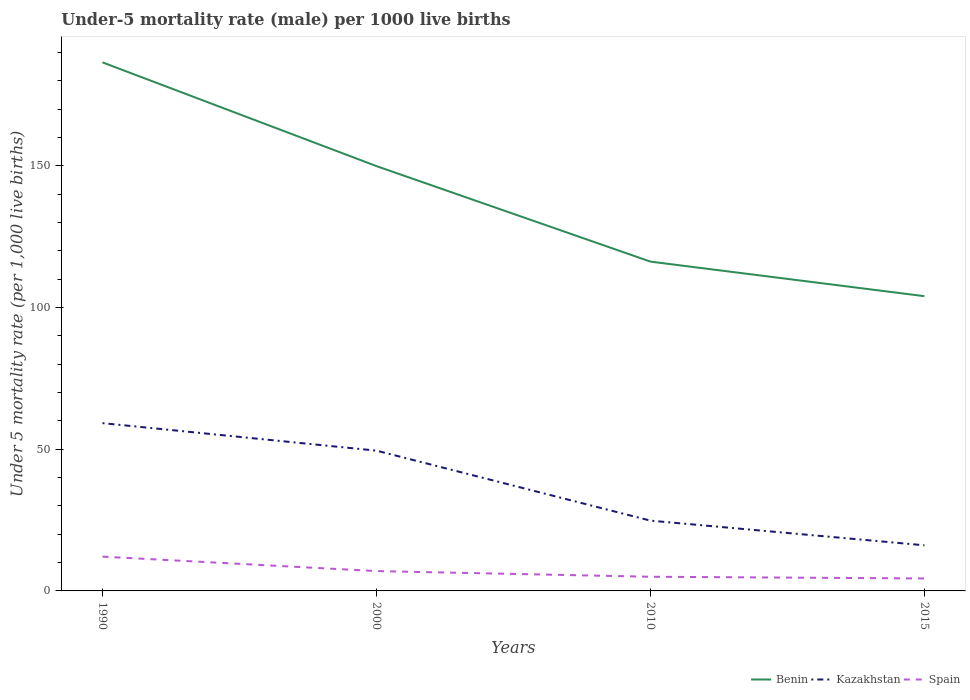How many different coloured lines are there?
Offer a very short reply. 3. Across all years, what is the maximum under-five mortality rate in Benin?
Provide a short and direct response. 104. In which year was the under-five mortality rate in Benin maximum?
Ensure brevity in your answer.  2015. What is the total under-five mortality rate in Kazakhstan in the graph?
Your answer should be compact. 33.4. What is the difference between the highest and the second highest under-five mortality rate in Spain?
Ensure brevity in your answer.  7.7. Is the under-five mortality rate in Kazakhstan strictly greater than the under-five mortality rate in Benin over the years?
Your answer should be very brief. Yes. How many lines are there?
Offer a very short reply. 3. How many years are there in the graph?
Offer a terse response. 4. What is the difference between two consecutive major ticks on the Y-axis?
Ensure brevity in your answer.  50. Does the graph contain any zero values?
Keep it short and to the point. No. Where does the legend appear in the graph?
Give a very brief answer. Bottom right. How many legend labels are there?
Make the answer very short. 3. How are the legend labels stacked?
Offer a terse response. Horizontal. What is the title of the graph?
Give a very brief answer. Under-5 mortality rate (male) per 1000 live births. What is the label or title of the X-axis?
Your response must be concise. Years. What is the label or title of the Y-axis?
Ensure brevity in your answer.  Under 5 mortality rate (per 1,0 live births). What is the Under 5 mortality rate (per 1,000 live births) of Benin in 1990?
Offer a very short reply. 186.5. What is the Under 5 mortality rate (per 1,000 live births) in Kazakhstan in 1990?
Provide a succinct answer. 59.2. What is the Under 5 mortality rate (per 1,000 live births) in Spain in 1990?
Make the answer very short. 12.1. What is the Under 5 mortality rate (per 1,000 live births) of Benin in 2000?
Your response must be concise. 149.9. What is the Under 5 mortality rate (per 1,000 live births) of Kazakhstan in 2000?
Give a very brief answer. 49.5. What is the Under 5 mortality rate (per 1,000 live births) in Spain in 2000?
Your response must be concise. 7. What is the Under 5 mortality rate (per 1,000 live births) in Benin in 2010?
Ensure brevity in your answer.  116.2. What is the Under 5 mortality rate (per 1,000 live births) of Kazakhstan in 2010?
Give a very brief answer. 24.8. What is the Under 5 mortality rate (per 1,000 live births) of Spain in 2010?
Give a very brief answer. 5. What is the Under 5 mortality rate (per 1,000 live births) in Benin in 2015?
Your answer should be compact. 104. Across all years, what is the maximum Under 5 mortality rate (per 1,000 live births) in Benin?
Ensure brevity in your answer.  186.5. Across all years, what is the maximum Under 5 mortality rate (per 1,000 live births) of Kazakhstan?
Offer a very short reply. 59.2. Across all years, what is the minimum Under 5 mortality rate (per 1,000 live births) of Benin?
Your answer should be very brief. 104. Across all years, what is the minimum Under 5 mortality rate (per 1,000 live births) in Kazakhstan?
Your answer should be compact. 16.1. Across all years, what is the minimum Under 5 mortality rate (per 1,000 live births) in Spain?
Offer a terse response. 4.4. What is the total Under 5 mortality rate (per 1,000 live births) of Benin in the graph?
Provide a succinct answer. 556.6. What is the total Under 5 mortality rate (per 1,000 live births) in Kazakhstan in the graph?
Make the answer very short. 149.6. What is the difference between the Under 5 mortality rate (per 1,000 live births) in Benin in 1990 and that in 2000?
Make the answer very short. 36.6. What is the difference between the Under 5 mortality rate (per 1,000 live births) in Benin in 1990 and that in 2010?
Offer a terse response. 70.3. What is the difference between the Under 5 mortality rate (per 1,000 live births) in Kazakhstan in 1990 and that in 2010?
Provide a succinct answer. 34.4. What is the difference between the Under 5 mortality rate (per 1,000 live births) in Benin in 1990 and that in 2015?
Your answer should be very brief. 82.5. What is the difference between the Under 5 mortality rate (per 1,000 live births) of Kazakhstan in 1990 and that in 2015?
Offer a very short reply. 43.1. What is the difference between the Under 5 mortality rate (per 1,000 live births) of Spain in 1990 and that in 2015?
Your answer should be compact. 7.7. What is the difference between the Under 5 mortality rate (per 1,000 live births) of Benin in 2000 and that in 2010?
Offer a terse response. 33.7. What is the difference between the Under 5 mortality rate (per 1,000 live births) in Kazakhstan in 2000 and that in 2010?
Your answer should be compact. 24.7. What is the difference between the Under 5 mortality rate (per 1,000 live births) in Spain in 2000 and that in 2010?
Make the answer very short. 2. What is the difference between the Under 5 mortality rate (per 1,000 live births) in Benin in 2000 and that in 2015?
Ensure brevity in your answer.  45.9. What is the difference between the Under 5 mortality rate (per 1,000 live births) in Kazakhstan in 2000 and that in 2015?
Your response must be concise. 33.4. What is the difference between the Under 5 mortality rate (per 1,000 live births) in Benin in 2010 and that in 2015?
Offer a terse response. 12.2. What is the difference between the Under 5 mortality rate (per 1,000 live births) in Benin in 1990 and the Under 5 mortality rate (per 1,000 live births) in Kazakhstan in 2000?
Give a very brief answer. 137. What is the difference between the Under 5 mortality rate (per 1,000 live births) of Benin in 1990 and the Under 5 mortality rate (per 1,000 live births) of Spain in 2000?
Provide a succinct answer. 179.5. What is the difference between the Under 5 mortality rate (per 1,000 live births) of Kazakhstan in 1990 and the Under 5 mortality rate (per 1,000 live births) of Spain in 2000?
Provide a short and direct response. 52.2. What is the difference between the Under 5 mortality rate (per 1,000 live births) in Benin in 1990 and the Under 5 mortality rate (per 1,000 live births) in Kazakhstan in 2010?
Provide a short and direct response. 161.7. What is the difference between the Under 5 mortality rate (per 1,000 live births) in Benin in 1990 and the Under 5 mortality rate (per 1,000 live births) in Spain in 2010?
Keep it short and to the point. 181.5. What is the difference between the Under 5 mortality rate (per 1,000 live births) of Kazakhstan in 1990 and the Under 5 mortality rate (per 1,000 live births) of Spain in 2010?
Give a very brief answer. 54.2. What is the difference between the Under 5 mortality rate (per 1,000 live births) of Benin in 1990 and the Under 5 mortality rate (per 1,000 live births) of Kazakhstan in 2015?
Your answer should be compact. 170.4. What is the difference between the Under 5 mortality rate (per 1,000 live births) of Benin in 1990 and the Under 5 mortality rate (per 1,000 live births) of Spain in 2015?
Keep it short and to the point. 182.1. What is the difference between the Under 5 mortality rate (per 1,000 live births) of Kazakhstan in 1990 and the Under 5 mortality rate (per 1,000 live births) of Spain in 2015?
Your answer should be very brief. 54.8. What is the difference between the Under 5 mortality rate (per 1,000 live births) in Benin in 2000 and the Under 5 mortality rate (per 1,000 live births) in Kazakhstan in 2010?
Provide a short and direct response. 125.1. What is the difference between the Under 5 mortality rate (per 1,000 live births) of Benin in 2000 and the Under 5 mortality rate (per 1,000 live births) of Spain in 2010?
Your answer should be compact. 144.9. What is the difference between the Under 5 mortality rate (per 1,000 live births) of Kazakhstan in 2000 and the Under 5 mortality rate (per 1,000 live births) of Spain in 2010?
Offer a very short reply. 44.5. What is the difference between the Under 5 mortality rate (per 1,000 live births) in Benin in 2000 and the Under 5 mortality rate (per 1,000 live births) in Kazakhstan in 2015?
Your response must be concise. 133.8. What is the difference between the Under 5 mortality rate (per 1,000 live births) in Benin in 2000 and the Under 5 mortality rate (per 1,000 live births) in Spain in 2015?
Give a very brief answer. 145.5. What is the difference between the Under 5 mortality rate (per 1,000 live births) of Kazakhstan in 2000 and the Under 5 mortality rate (per 1,000 live births) of Spain in 2015?
Provide a short and direct response. 45.1. What is the difference between the Under 5 mortality rate (per 1,000 live births) of Benin in 2010 and the Under 5 mortality rate (per 1,000 live births) of Kazakhstan in 2015?
Your response must be concise. 100.1. What is the difference between the Under 5 mortality rate (per 1,000 live births) of Benin in 2010 and the Under 5 mortality rate (per 1,000 live births) of Spain in 2015?
Offer a terse response. 111.8. What is the difference between the Under 5 mortality rate (per 1,000 live births) in Kazakhstan in 2010 and the Under 5 mortality rate (per 1,000 live births) in Spain in 2015?
Offer a terse response. 20.4. What is the average Under 5 mortality rate (per 1,000 live births) in Benin per year?
Offer a terse response. 139.15. What is the average Under 5 mortality rate (per 1,000 live births) in Kazakhstan per year?
Your answer should be compact. 37.4. What is the average Under 5 mortality rate (per 1,000 live births) in Spain per year?
Keep it short and to the point. 7.12. In the year 1990, what is the difference between the Under 5 mortality rate (per 1,000 live births) of Benin and Under 5 mortality rate (per 1,000 live births) of Kazakhstan?
Offer a terse response. 127.3. In the year 1990, what is the difference between the Under 5 mortality rate (per 1,000 live births) of Benin and Under 5 mortality rate (per 1,000 live births) of Spain?
Your answer should be compact. 174.4. In the year 1990, what is the difference between the Under 5 mortality rate (per 1,000 live births) of Kazakhstan and Under 5 mortality rate (per 1,000 live births) of Spain?
Ensure brevity in your answer.  47.1. In the year 2000, what is the difference between the Under 5 mortality rate (per 1,000 live births) of Benin and Under 5 mortality rate (per 1,000 live births) of Kazakhstan?
Your answer should be very brief. 100.4. In the year 2000, what is the difference between the Under 5 mortality rate (per 1,000 live births) of Benin and Under 5 mortality rate (per 1,000 live births) of Spain?
Give a very brief answer. 142.9. In the year 2000, what is the difference between the Under 5 mortality rate (per 1,000 live births) in Kazakhstan and Under 5 mortality rate (per 1,000 live births) in Spain?
Your response must be concise. 42.5. In the year 2010, what is the difference between the Under 5 mortality rate (per 1,000 live births) in Benin and Under 5 mortality rate (per 1,000 live births) in Kazakhstan?
Ensure brevity in your answer.  91.4. In the year 2010, what is the difference between the Under 5 mortality rate (per 1,000 live births) of Benin and Under 5 mortality rate (per 1,000 live births) of Spain?
Provide a succinct answer. 111.2. In the year 2010, what is the difference between the Under 5 mortality rate (per 1,000 live births) of Kazakhstan and Under 5 mortality rate (per 1,000 live births) of Spain?
Offer a terse response. 19.8. In the year 2015, what is the difference between the Under 5 mortality rate (per 1,000 live births) in Benin and Under 5 mortality rate (per 1,000 live births) in Kazakhstan?
Your answer should be very brief. 87.9. In the year 2015, what is the difference between the Under 5 mortality rate (per 1,000 live births) of Benin and Under 5 mortality rate (per 1,000 live births) of Spain?
Keep it short and to the point. 99.6. What is the ratio of the Under 5 mortality rate (per 1,000 live births) of Benin in 1990 to that in 2000?
Keep it short and to the point. 1.24. What is the ratio of the Under 5 mortality rate (per 1,000 live births) in Kazakhstan in 1990 to that in 2000?
Ensure brevity in your answer.  1.2. What is the ratio of the Under 5 mortality rate (per 1,000 live births) of Spain in 1990 to that in 2000?
Make the answer very short. 1.73. What is the ratio of the Under 5 mortality rate (per 1,000 live births) of Benin in 1990 to that in 2010?
Provide a succinct answer. 1.6. What is the ratio of the Under 5 mortality rate (per 1,000 live births) in Kazakhstan in 1990 to that in 2010?
Your answer should be compact. 2.39. What is the ratio of the Under 5 mortality rate (per 1,000 live births) of Spain in 1990 to that in 2010?
Offer a terse response. 2.42. What is the ratio of the Under 5 mortality rate (per 1,000 live births) of Benin in 1990 to that in 2015?
Your response must be concise. 1.79. What is the ratio of the Under 5 mortality rate (per 1,000 live births) of Kazakhstan in 1990 to that in 2015?
Ensure brevity in your answer.  3.68. What is the ratio of the Under 5 mortality rate (per 1,000 live births) in Spain in 1990 to that in 2015?
Offer a terse response. 2.75. What is the ratio of the Under 5 mortality rate (per 1,000 live births) in Benin in 2000 to that in 2010?
Ensure brevity in your answer.  1.29. What is the ratio of the Under 5 mortality rate (per 1,000 live births) of Kazakhstan in 2000 to that in 2010?
Ensure brevity in your answer.  2. What is the ratio of the Under 5 mortality rate (per 1,000 live births) of Benin in 2000 to that in 2015?
Provide a short and direct response. 1.44. What is the ratio of the Under 5 mortality rate (per 1,000 live births) in Kazakhstan in 2000 to that in 2015?
Your response must be concise. 3.07. What is the ratio of the Under 5 mortality rate (per 1,000 live births) of Spain in 2000 to that in 2015?
Ensure brevity in your answer.  1.59. What is the ratio of the Under 5 mortality rate (per 1,000 live births) in Benin in 2010 to that in 2015?
Offer a terse response. 1.12. What is the ratio of the Under 5 mortality rate (per 1,000 live births) of Kazakhstan in 2010 to that in 2015?
Offer a very short reply. 1.54. What is the ratio of the Under 5 mortality rate (per 1,000 live births) of Spain in 2010 to that in 2015?
Ensure brevity in your answer.  1.14. What is the difference between the highest and the second highest Under 5 mortality rate (per 1,000 live births) in Benin?
Provide a succinct answer. 36.6. What is the difference between the highest and the second highest Under 5 mortality rate (per 1,000 live births) of Spain?
Provide a short and direct response. 5.1. What is the difference between the highest and the lowest Under 5 mortality rate (per 1,000 live births) in Benin?
Make the answer very short. 82.5. What is the difference between the highest and the lowest Under 5 mortality rate (per 1,000 live births) of Kazakhstan?
Give a very brief answer. 43.1. 